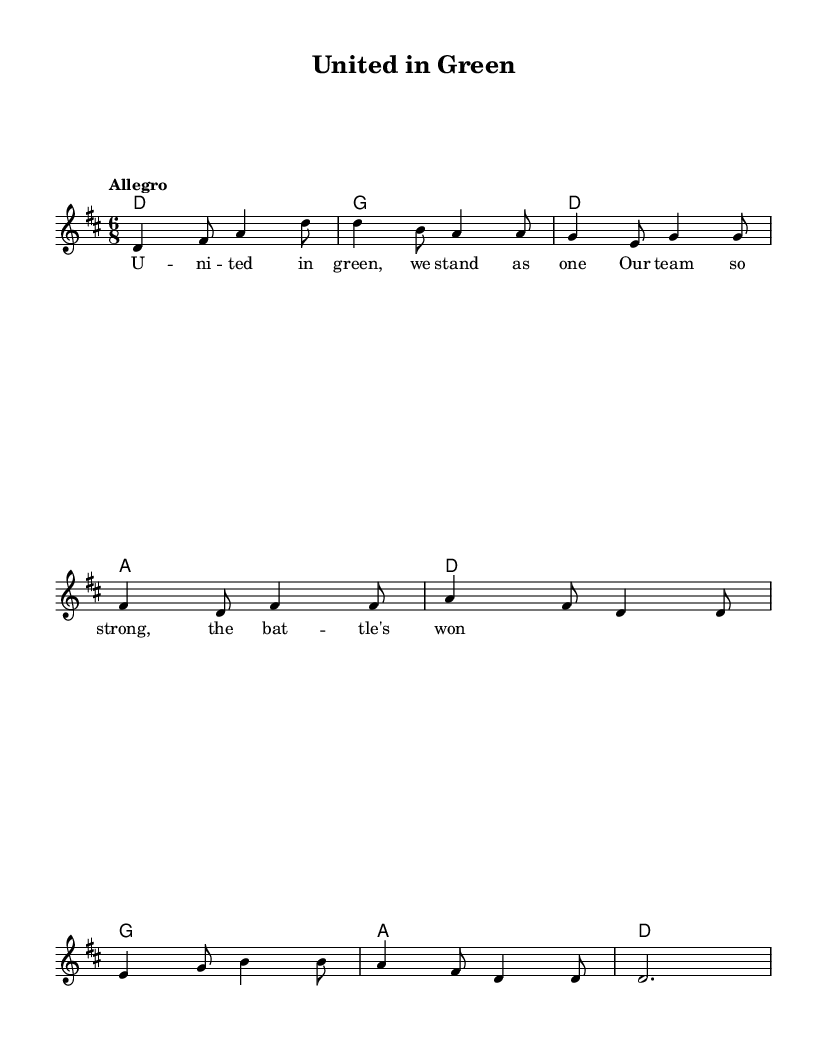What is the key signature of this music? The key signature is D major, which has two sharps (F# and C#). This can be observed in the key indication at the beginning of the score.
Answer: D major What is the time signature of this music? The time signature is 6/8, which is indicated at the beginning of the music. This means there are six eighth notes per measure.
Answer: 6/8 What is the tempo marking of this piece? The tempo marking is "Allegro", which is typically indicated at the start of the music. This indicates a brisk and lively pace.
Answer: Allegro How many measures are there in the melody? By counting the measures in the melody, there are eight measures total, which is typically indicated by the musical notation.
Answer: Eight What is the first line of the lyrics? The first line of the lyrics, positioned under the melody notes, is "United in green, we stand as one." This can be found at the beginning of the lyric section.
Answer: United in green, we stand as one What chords accompany the first measure of the melody? The chords in the first measure are D major, as indicated by the chord symbols placed above the staff. The alignment with the melody note confirms this.
Answer: D major What theme do the lyrics convey? The theme of the lyrics conveys unity and strength among the team, focusing on victory and collective effort, evidenced by the words used.
Answer: Unity and strength 